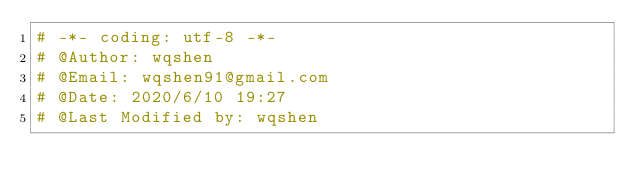Convert code to text. <code><loc_0><loc_0><loc_500><loc_500><_Python_># -*- coding: utf-8 -*-
# @Author: wqshen
# @Email: wqshen91@gmail.com
# @Date: 2020/6/10 19:27
# @Last Modified by: wqshen</code> 